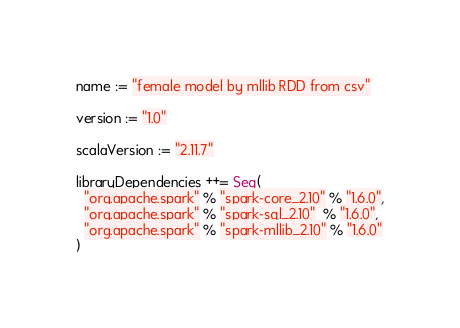Convert code to text. <code><loc_0><loc_0><loc_500><loc_500><_Scala_>name := "female model by mllib RDD from csv"

version := "1.0"

scalaVersion := "2.11.7"

libraryDependencies ++= Seq(
  "org.apache.spark" % "spark-core_2.10" % "1.6.0",
  "org.apache.spark" % "spark-sql_2.10"  % "1.6.0",
  "org.apache.spark" % "spark-mllib_2.10" % "1.6.0"
)
</code> 